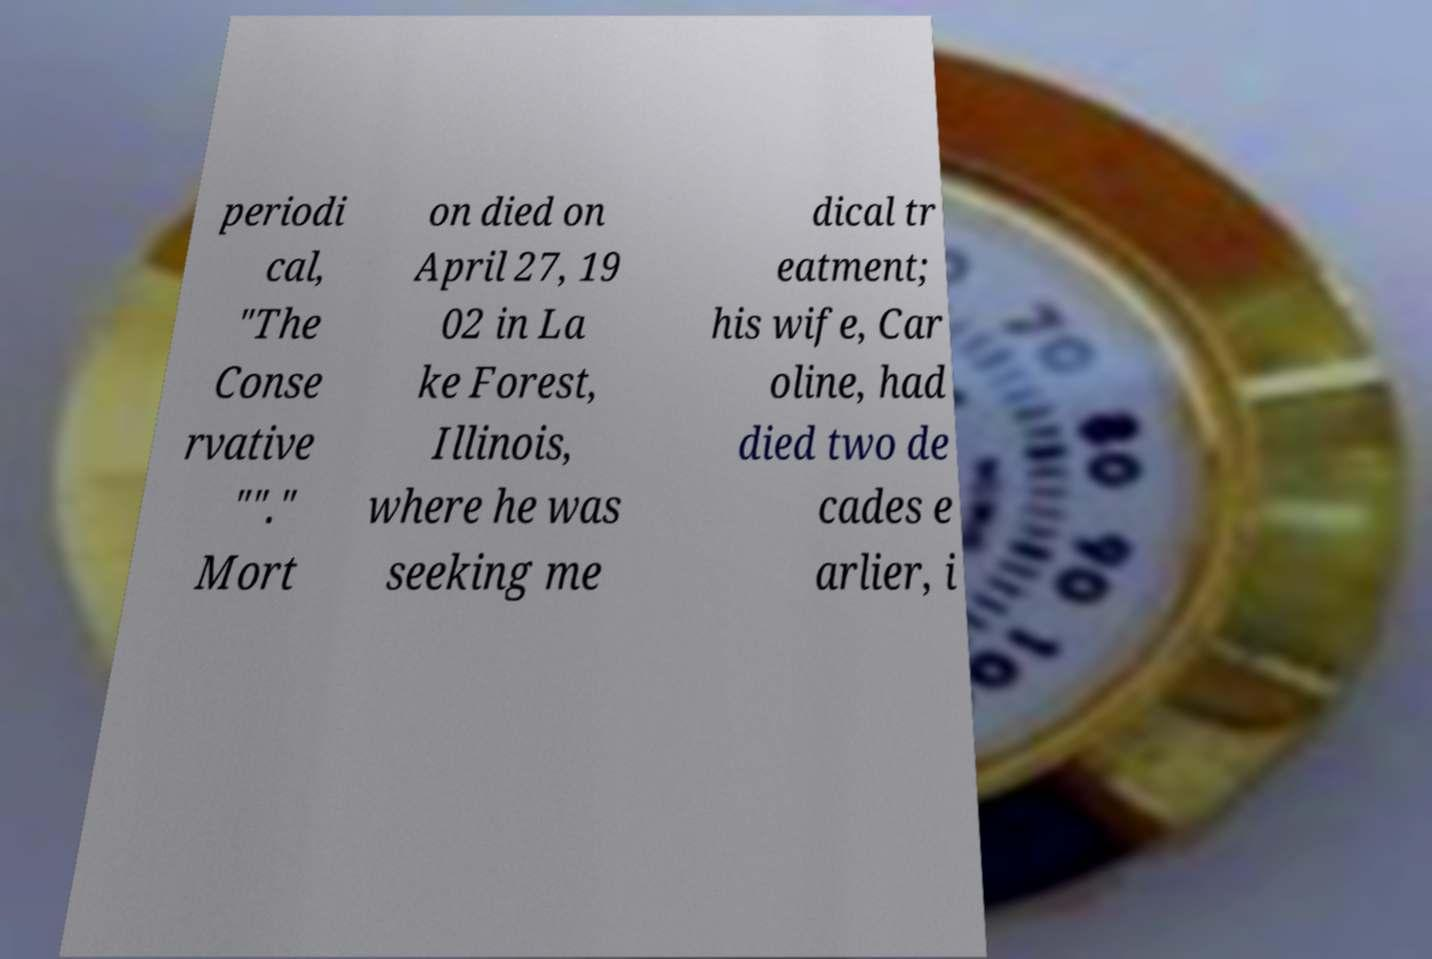For documentation purposes, I need the text within this image transcribed. Could you provide that? periodi cal, "The Conse rvative ""." Mort on died on April 27, 19 02 in La ke Forest, Illinois, where he was seeking me dical tr eatment; his wife, Car oline, had died two de cades e arlier, i 